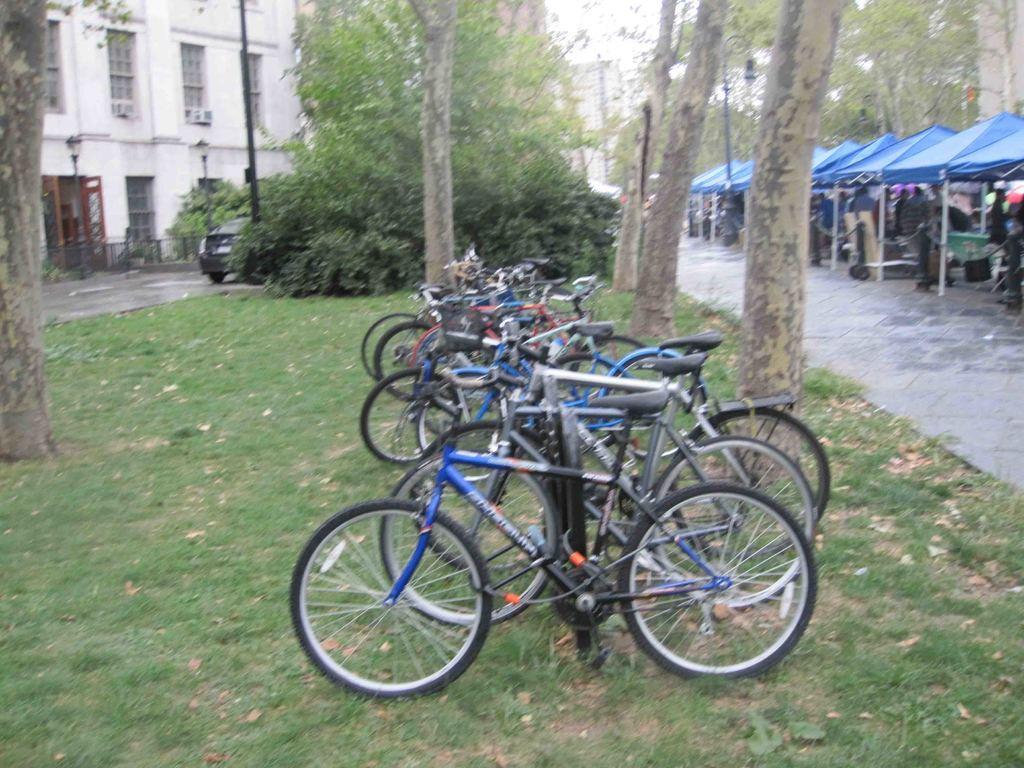Describe this image in one or two sentences. In this picture there are bicycles in the middle of the image. On the right side of the image there are group of people under the tent. On the left side the image there is a building and there is a vehicle. At the back there are trees and poles. At the bottom there is a road and there is grass. 